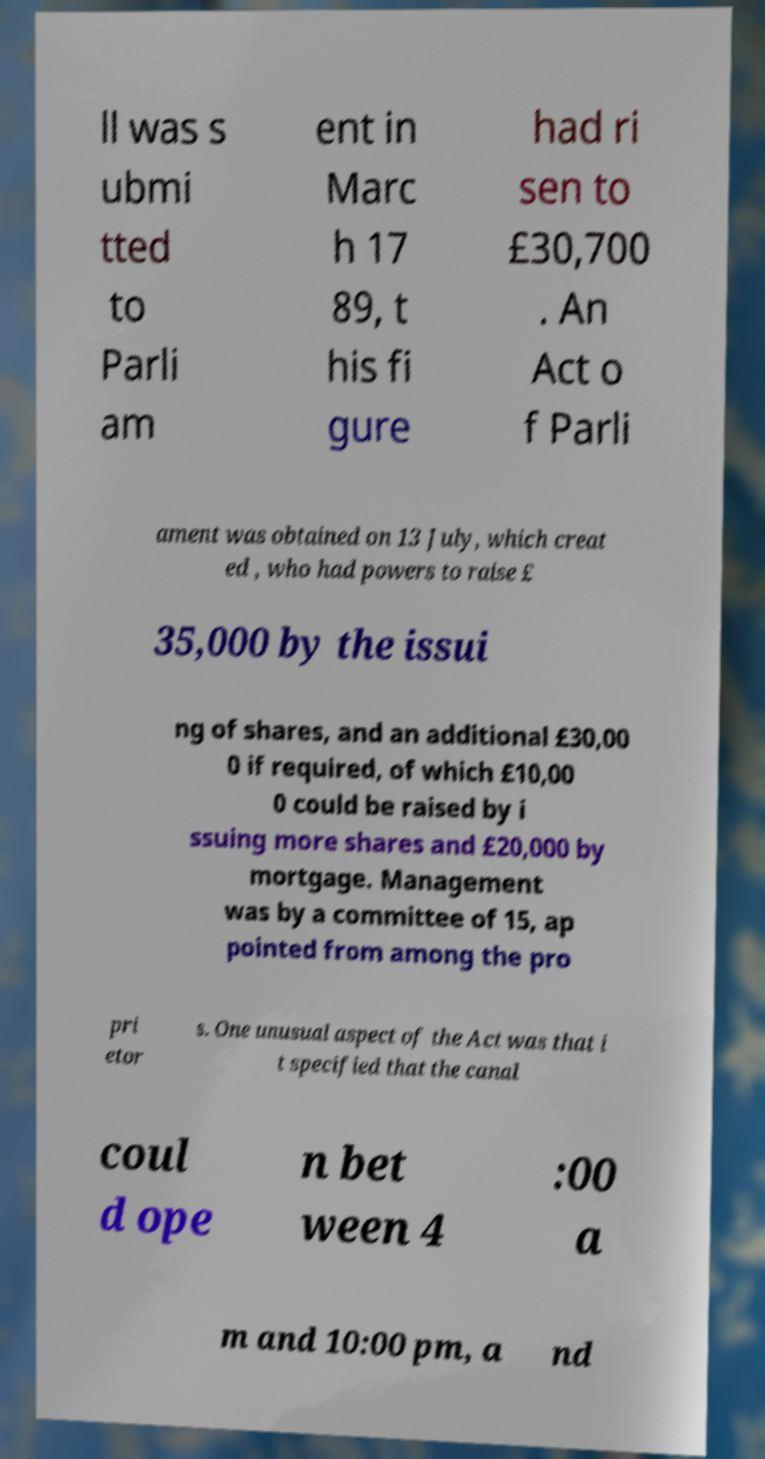What messages or text are displayed in this image? I need them in a readable, typed format. ll was s ubmi tted to Parli am ent in Marc h 17 89, t his fi gure had ri sen to £30,700 . An Act o f Parli ament was obtained on 13 July, which creat ed , who had powers to raise £ 35,000 by the issui ng of shares, and an additional £30,00 0 if required, of which £10,00 0 could be raised by i ssuing more shares and £20,000 by mortgage. Management was by a committee of 15, ap pointed from among the pro pri etor s. One unusual aspect of the Act was that i t specified that the canal coul d ope n bet ween 4 :00 a m and 10:00 pm, a nd 